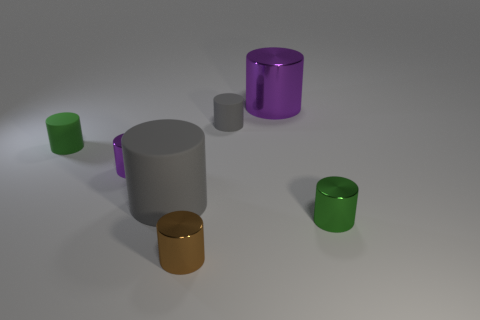Subtract all large purple cylinders. How many cylinders are left? 6 Add 1 large purple objects. How many objects exist? 8 Subtract all brown cylinders. How many cylinders are left? 6 Subtract all red blocks. How many purple cylinders are left? 2 Subtract 0 blue cylinders. How many objects are left? 7 Subtract 3 cylinders. How many cylinders are left? 4 Subtract all green cylinders. Subtract all yellow cubes. How many cylinders are left? 5 Subtract all small metallic cylinders. Subtract all green objects. How many objects are left? 2 Add 7 large gray rubber objects. How many large gray rubber objects are left? 8 Add 1 metallic things. How many metallic things exist? 5 